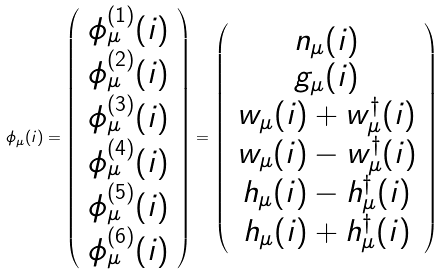<formula> <loc_0><loc_0><loc_500><loc_500>\phi _ { \mu } ( i ) = \left ( \begin{array} { c } \phi ^ { ( 1 ) } _ { \mu } ( i ) \\ \phi ^ { ( 2 ) } _ { \mu } ( i ) \\ \phi ^ { ( 3 ) } _ { \mu } ( i ) \\ \phi ^ { ( 4 ) } _ { \mu } ( i ) \\ \phi ^ { ( 5 ) } _ { \mu } ( i ) \\ \phi ^ { ( 6 ) } _ { \mu } ( i ) \end{array} \right ) = \left ( \begin{array} { c } n _ { \mu } ( i ) \\ g _ { \mu } ( i ) \\ w _ { \mu } ( i ) + w _ { \mu } ^ { \dagger } ( i ) \\ w _ { \mu } ( i ) - w _ { \mu } ^ { \dagger } ( i ) \\ h _ { \mu } ( i ) - h _ { \mu } ^ { \dagger } ( i ) \\ h _ { \mu } ( i ) + h _ { \mu } ^ { \dagger } ( i ) \end{array} \right )</formula> 